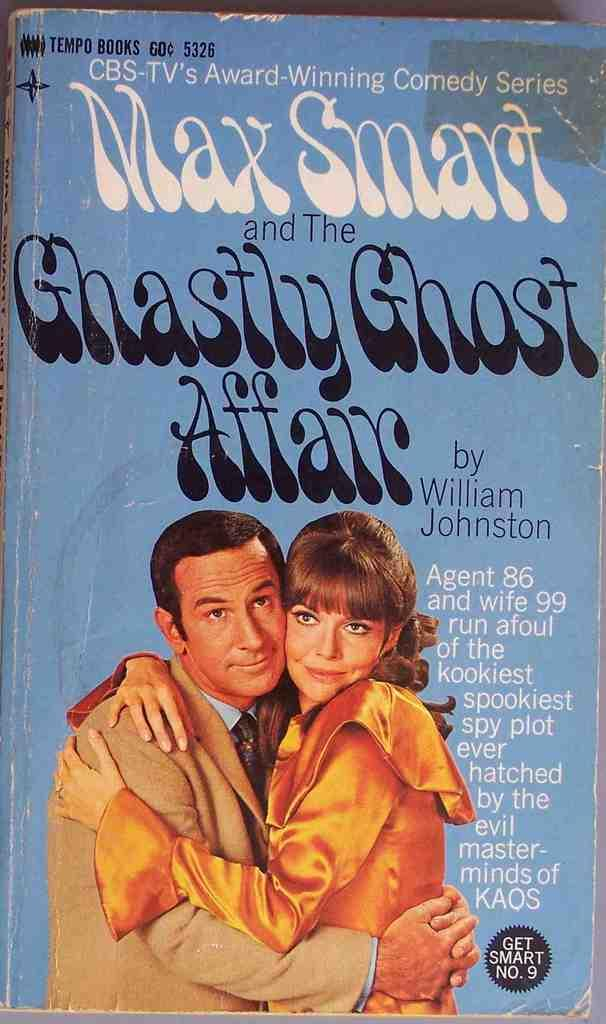<image>
Give a short and clear explanation of the subsequent image. A book titled Max Smart and The Ghastly Ghost Affair. 